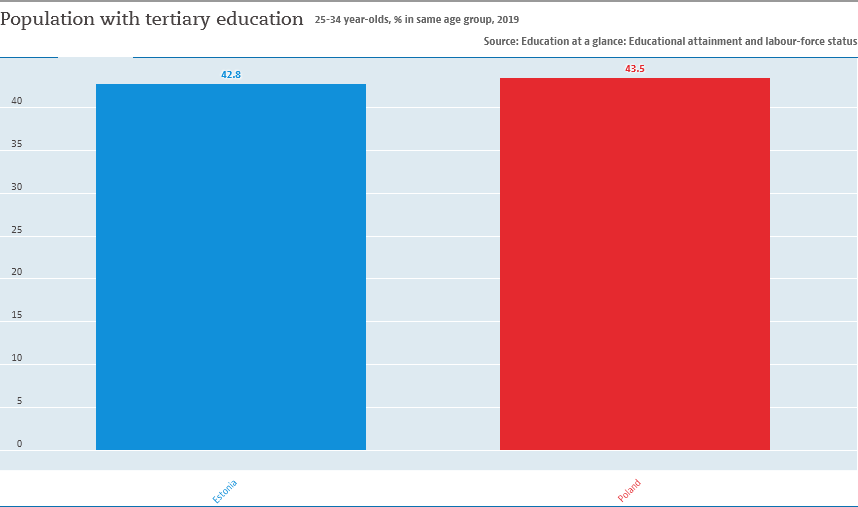Indicate a few pertinent items in this graphic. According to the data provided, the difference in population with tertiary education between Poland and Estonia is 0.7%. The larger bar is red. 